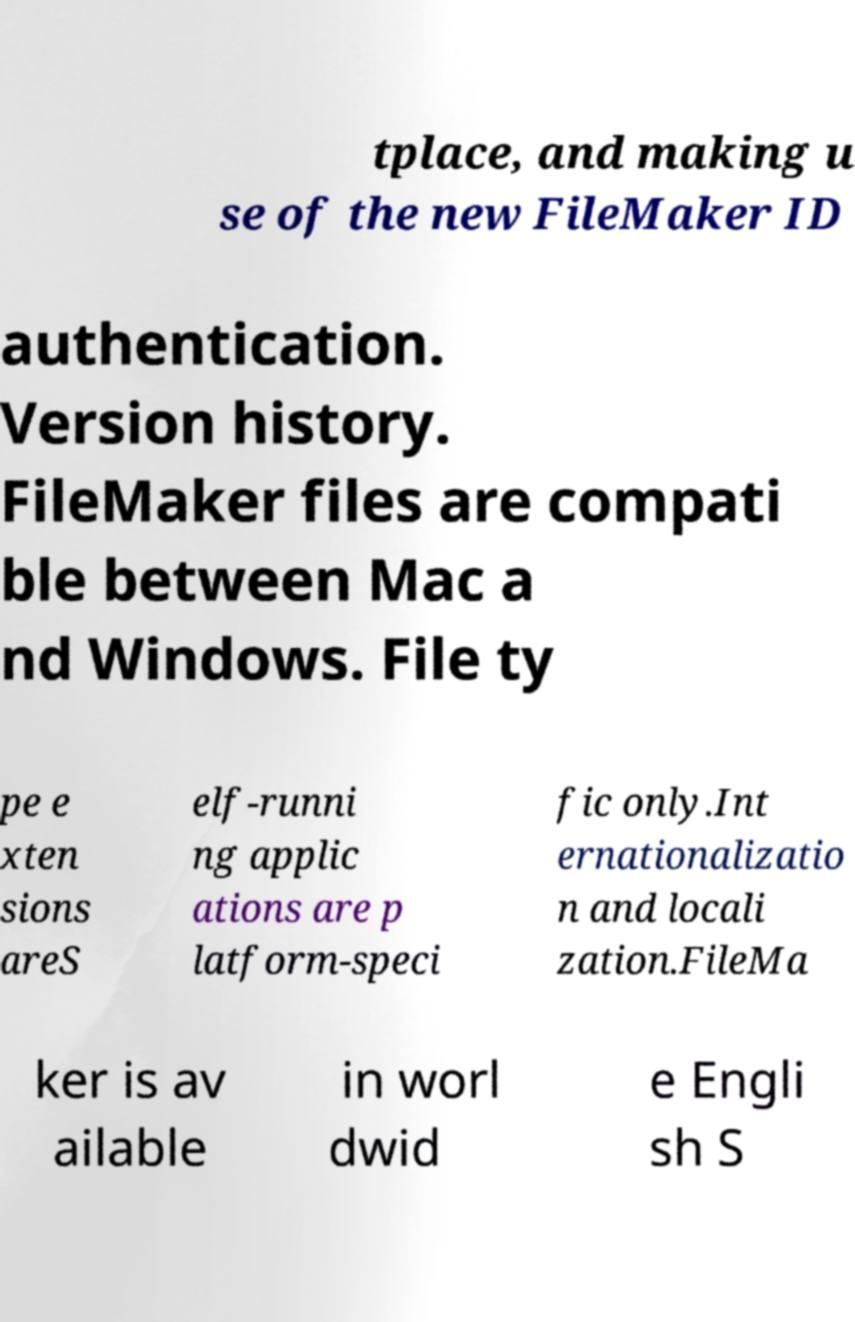Can you accurately transcribe the text from the provided image for me? tplace, and making u se of the new FileMaker ID authentication. Version history. FileMaker files are compati ble between Mac a nd Windows. File ty pe e xten sions areS elf-runni ng applic ations are p latform-speci fic only.Int ernationalizatio n and locali zation.FileMa ker is av ailable in worl dwid e Engli sh S 